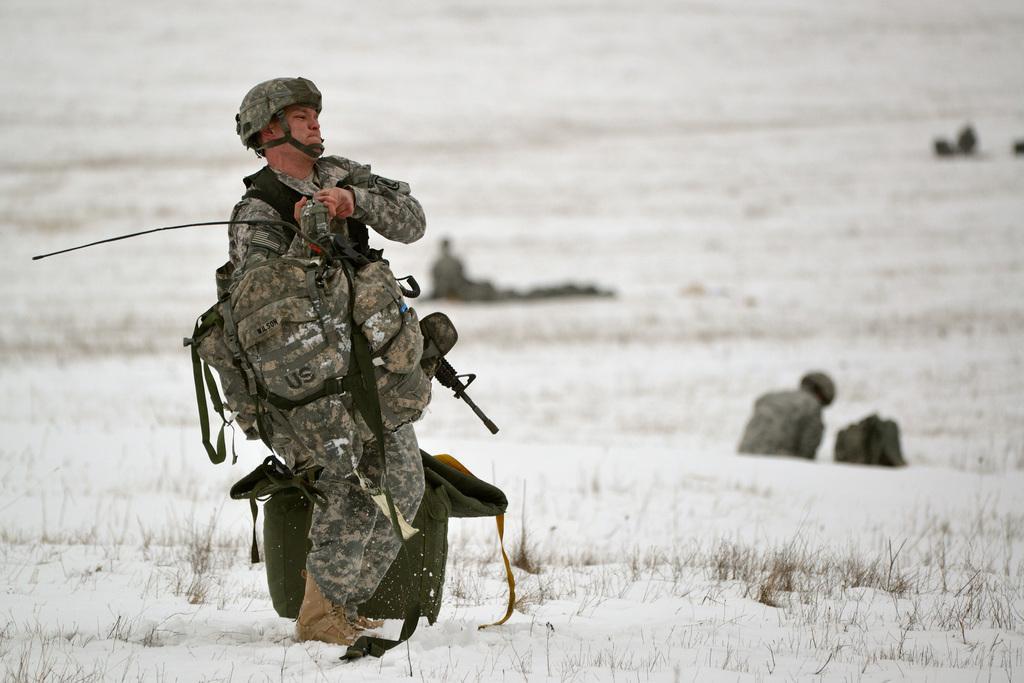How would you summarize this image in a sentence or two? In this image we can see a person wearing a helmet, gun and a bag standing on the ice. On the backside we can see some people sitting on the ground. 